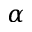<formula> <loc_0><loc_0><loc_500><loc_500>\alpha</formula> 